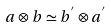<formula> <loc_0><loc_0><loc_500><loc_500>a \otimes b \simeq b ^ { ^ { \prime } } \otimes a ^ { ^ { \prime } }</formula> 